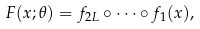<formula> <loc_0><loc_0><loc_500><loc_500>F ( x ; \theta ) & = f _ { 2 L } \circ \cdots \circ f _ { 1 } ( x ) ,</formula> 